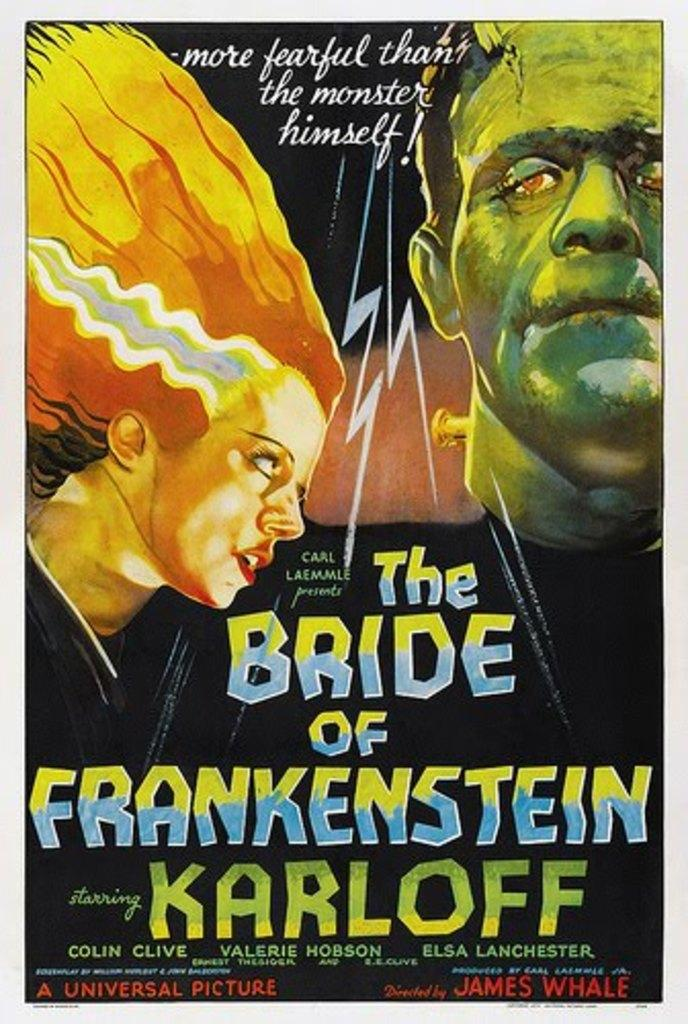Provide a one-sentence caption for the provided image. The cover of the movie The Bride of Frankenstien. 